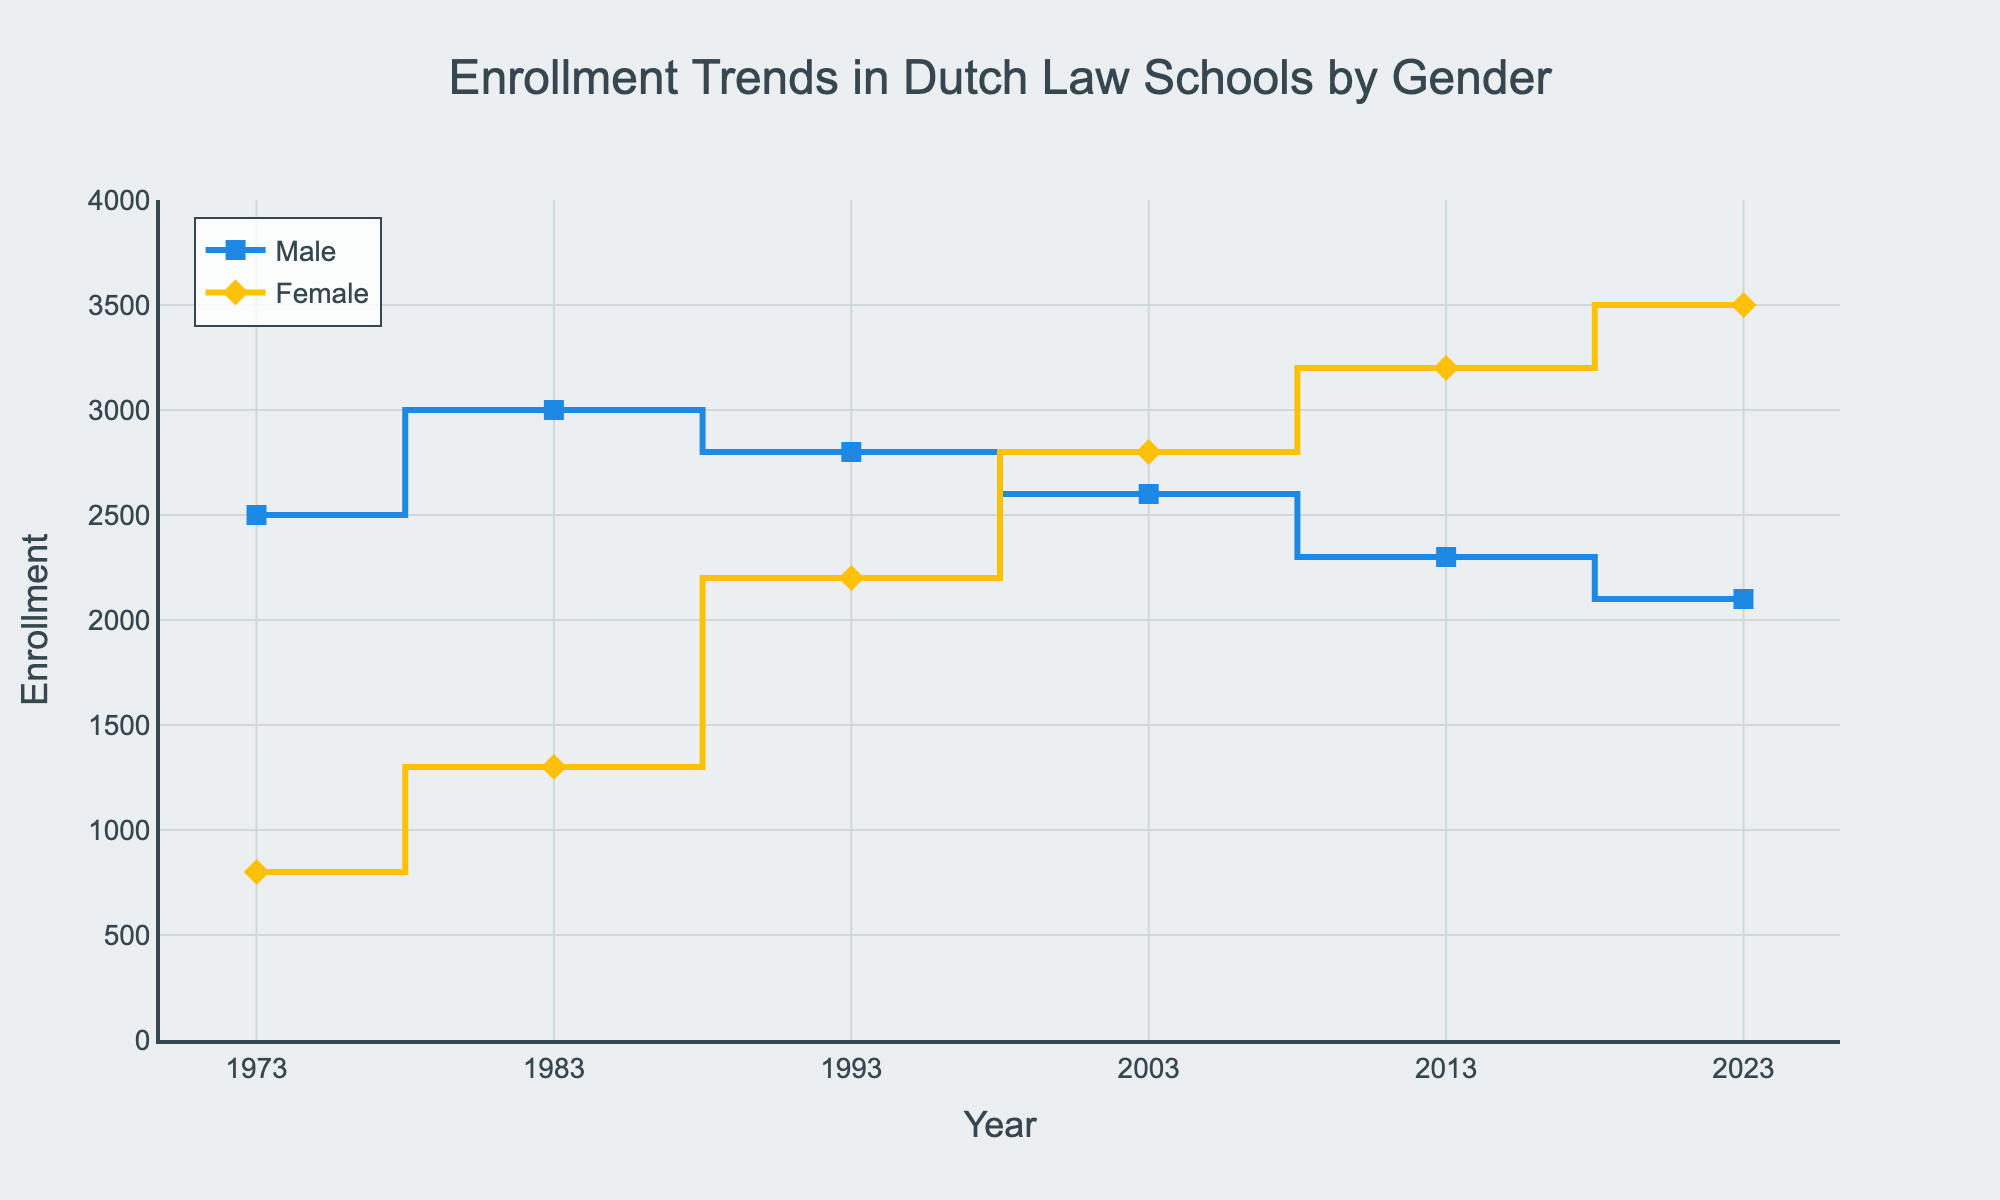What is the title of the plot? The title of the plot is typically displayed at the top center of the figure. In this case, it is clearly stated as 'Enrollment Trends in Dutch Law Schools by Gender.'
Answer: Enrollment Trends in Dutch Law Schools by Gender How many years are represented in the plot? The x-axis of the plot displays the years. By counting unique years that appear on the x-axis, we notice the years 1973, 1983, 1993, 2003, 2013, and 2023, which totals to 6 years.
Answer: 6 What color represents male enrollment? The lines and markers representing the male enrollment are highlighted in a specific color. Here, the plot uses a blue color to denote male enrollment.
Answer: Blue When did female enrollment surpass male enrollment? By inspecting the points where the yellow line (representing female enrollment) surpasses the blue line (representing male enrollment), it can be identified that female enrollment surpasses male enrollment starting from the year 2003.
Answer: 2003 What was the enrollment for females in 2023? To determine the female enrollment in 2023, locate the data point on the yellow line corresponding to the year 2023 on the x-axis, which shows an enrollment of 3500.
Answer: 3500 In which year did male enrollment peak and what was the enrollment number? Observing the blue line’s highest point will indicate the year when the male enrollment was at its peak. The peak of the male enrollment is at the year 1983, with an enrollment of 3000.
Answer: 1983, 3000 How did the total (male + female) enrollment change from 1973 to 2023? Calculate the total enrollment for each year and compare the years 1973 and 2023. In 1973, the total enrollment is 2500 (male) + 800 (female) = 3300. In 2023, the total enrollment is 2100 (male) + 3500 (female) = 5600. The total enrollment increased from 3300 to 5600.
Answer: Increased by 2300 What is the average male enrollment over the 50-year period? Add up the male enrollment numbers for all years and divide by the number of years. (2500 + 3000 + 2800 + 2600 + 2300 + 2100)/6 = 25300/6 ≈ 2583.33.
Answer: 2583.33 Compare the rates of decline for male and female enrollments from their peaks to 2023. First, find the peak enrollments: males in 1983 (3000) and females in 2023 (3500). Compute the decline for males: (3000 - 2100)/3000 = 0.3 or 30%. For females, there is no decline as 2023 is the peak year for females.
Answer: Male: 30%, Female: 0% How does the trend in male enrollment compare to the trend in female enrollment over the 50 years? The blue line for males shows a general downward trend with peaks in the early years and declining thereafter. The yellow line for females shows a steady upward trend, starting lower than males but surpassing them and reaching its highest point in the last data year.
Answer: Male: Downward trend, Female: Upward trend 